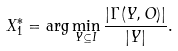Convert formula to latex. <formula><loc_0><loc_0><loc_500><loc_500>X ^ { * } _ { 1 } = \arg \min _ { Y \subseteq I } \frac { | \Gamma ( Y , O ) | } { | Y | } .</formula> 